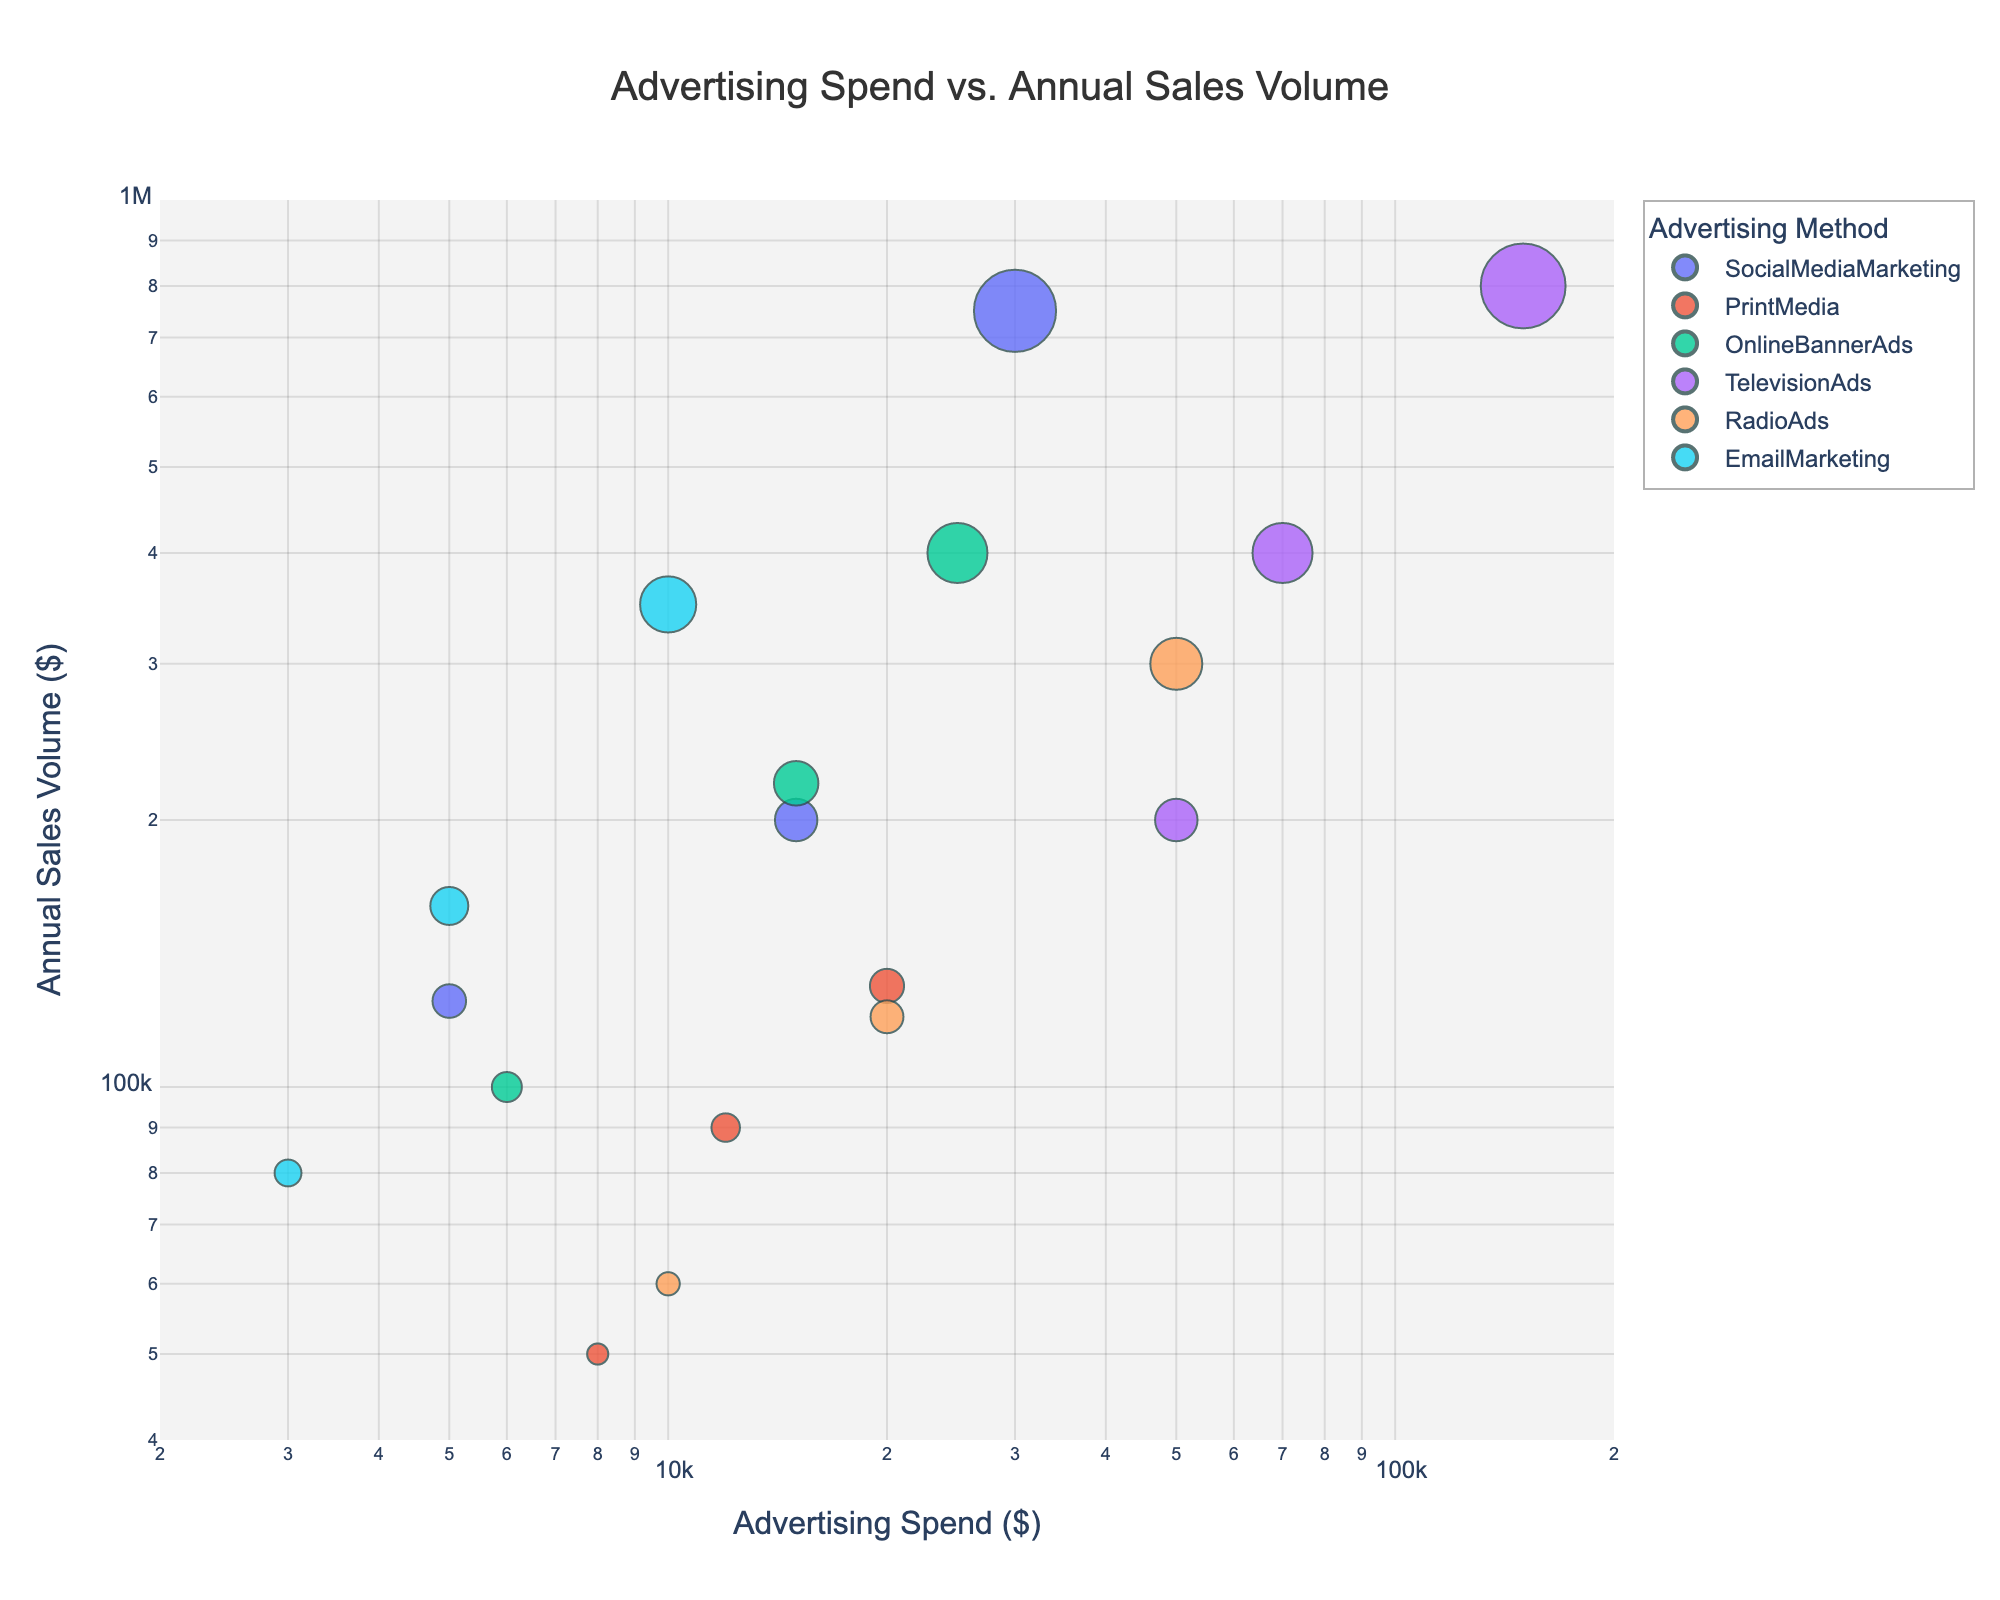What is the title of the plot? The title of the plot is displayed at the top center of the figure. It is in a larger font size compared to other text elements.
Answer: Advertising Spend vs. Annual Sales Volume How many different advertising methods are represented in the plot? There are different colors representing different advertising methods in the legend on the right-hand side of the plot. Counting these distinct colors gives the number of methods.
Answer: 5 What does the size of each point represent? The size of the points is directly related to another variable because some points are larger than others. The legend or a note in the figure elaborates on what the size signifies.
Answer: Annual Sales Volume Which advertising method had the highest annual sales volume? By looking at the largest point on the y-axis at a high value, we can identify it through its color and hover text.
Answer: Television Ads What is the trend line indicating? The trend line in the plot helps to visualize the general direction of the data points. It usually indicates the correlation between advertising spend and annual sales volume.
Answer: Positive correlation Which advertising method had an advertising spend of over $100,000? The log-scaled x-axis helps to locate the point representing an advertising spend of over $100,000. The corresponding method can be found by checking the hover text and color.
Answer: Television Ads How does the annual sales volume for Social Media Marketing compare with Online Banner Ads at the same advertising spend level? By finding points representing Social Media Marketing and Online Banner Ads with the same x-coordinate (advertising spend), their respective y-coordinates (annual sales volumes) can be compared.
Answer: Varies, generally comparable What is the range of advertising spend values in the plot? The x-axis range showcases values for advertising spend, noted by the minimum and maximum displayed values on the log scale.
Answer: $2000 to $200,000 What can be inferred about the relationship between advertising spend and annual sales volume? The trend line helps in inferring the relationship. More spending seems to correlate with higher sales, represented by an upward trend.
Answer: Positive correlation What is the smallest annual sales volume in the plot, and which advertising method does it correspond to? The smallest point on the y-axis indicates the smallest annual sales volume. Hover text or color corresponding to this point tells the advertising method.
Answer: Print Media at $50,000 